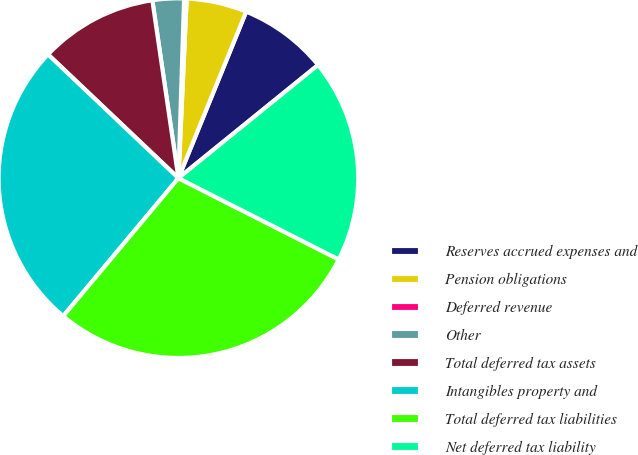Convert chart. <chart><loc_0><loc_0><loc_500><loc_500><pie_chart><fcel>Reserves accrued expenses and<fcel>Pension obligations<fcel>Deferred revenue<fcel>Other<fcel>Total deferred tax assets<fcel>Intangibles property and<fcel>Total deferred tax liabilities<fcel>Net deferred tax liability<nl><fcel>8.01%<fcel>5.42%<fcel>0.23%<fcel>2.82%<fcel>10.6%<fcel>26.01%<fcel>28.6%<fcel>18.31%<nl></chart> 